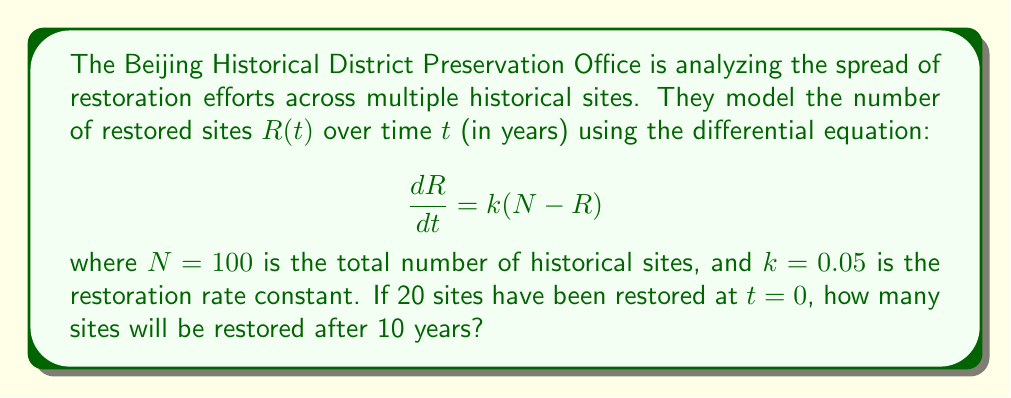Could you help me with this problem? To solve this first-order linear differential equation, we follow these steps:

1) The general solution for this type of equation is:

   $$R(t) = N - (N - R_0)e^{-kt}$$

   where $R_0$ is the initial number of restored sites.

2) We're given:
   - $N = 100$ (total sites)
   - $k = 0.05$ (restoration rate constant)
   - $R_0 = 20$ (initial restored sites at $t = 0$)
   - We need to find $R(10)$

3) Substituting these values into our solution:

   $$R(t) = 100 - (100 - 20)e^{-0.05t}$$
   $$R(t) = 100 - 80e^{-0.05t}$$

4) Now, we can calculate $R(10)$:

   $$R(10) = 100 - 80e^{-0.05(10)}$$
   $$R(10) = 100 - 80e^{-0.5}$$
   $$R(10) = 100 - 80(0.6065)$$
   $$R(10) = 100 - 48.52$$
   $$R(10) = 51.48$$

5) Since we're dealing with whole sites, we round to the nearest integer.
Answer: After 10 years, approximately 51 historical sites will be restored. 